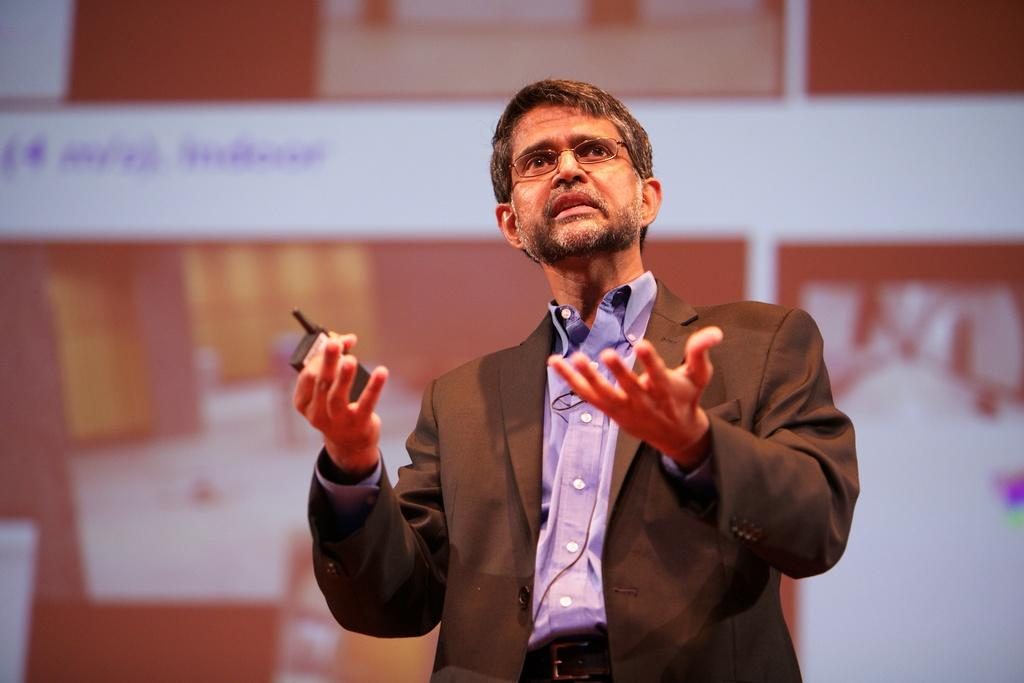Who is present in the image? There is a man in the image. What is the man wearing? The man is wearing a blazer and spectacles. What is the man holding in his hand? The man is holding a device in his hand. Can you describe the background of the image? The background of the image is blurry. What type of wing is visible on the man's back in the image? There is no wing visible on the man's back in the image. What religion does the man in the image practice? There is no information about the man's religion in the image. What type of sofa is present in the image? There is no sofa present in the image. 